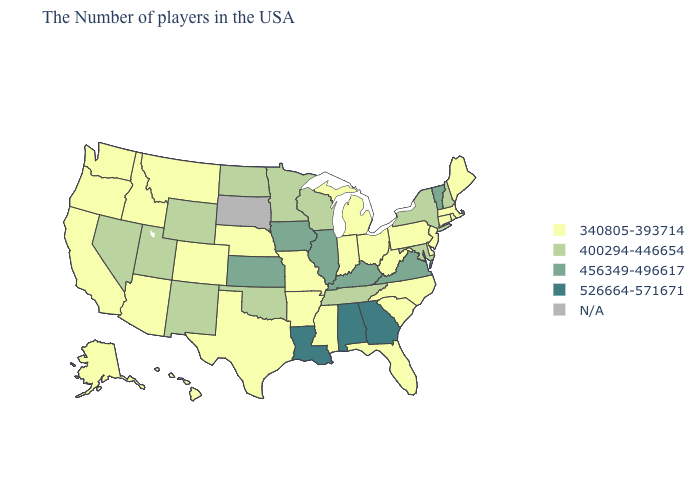What is the value of New York?
Short answer required. 400294-446654. Does Kansas have the lowest value in the MidWest?
Give a very brief answer. No. Does Georgia have the highest value in the USA?
Give a very brief answer. Yes. What is the highest value in states that border Illinois?
Keep it brief. 456349-496617. Does Kansas have the lowest value in the USA?
Keep it brief. No. Does the map have missing data?
Give a very brief answer. Yes. What is the highest value in the South ?
Answer briefly. 526664-571671. What is the value of Arizona?
Quick response, please. 340805-393714. Which states have the lowest value in the MidWest?
Concise answer only. Ohio, Michigan, Indiana, Missouri, Nebraska. Name the states that have a value in the range 456349-496617?
Write a very short answer. Vermont, Virginia, Kentucky, Illinois, Iowa, Kansas. Among the states that border North Dakota , does Montana have the highest value?
Answer briefly. No. Does Massachusetts have the highest value in the USA?
Short answer required. No. What is the lowest value in states that border West Virginia?
Short answer required. 340805-393714. 